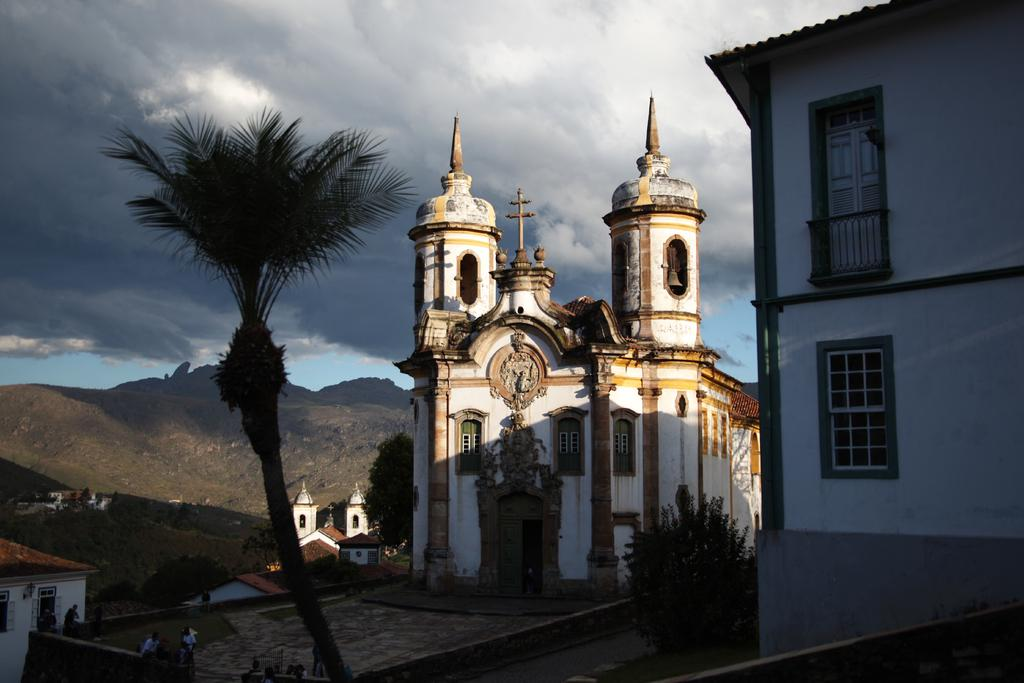What type of structures can be seen in the image? There are houses in the image. What other natural elements are present in the image? There are plants, trees, and a mountain visible in the image. Are there any living beings in the image? Yes, there are people in the image. What can be seen in the background of the image? There is sky visible in the background of the image, with clouds present. What statement does the stranger make about the mountain in the image? There is no stranger present in the image, so no statement can be attributed to them. 